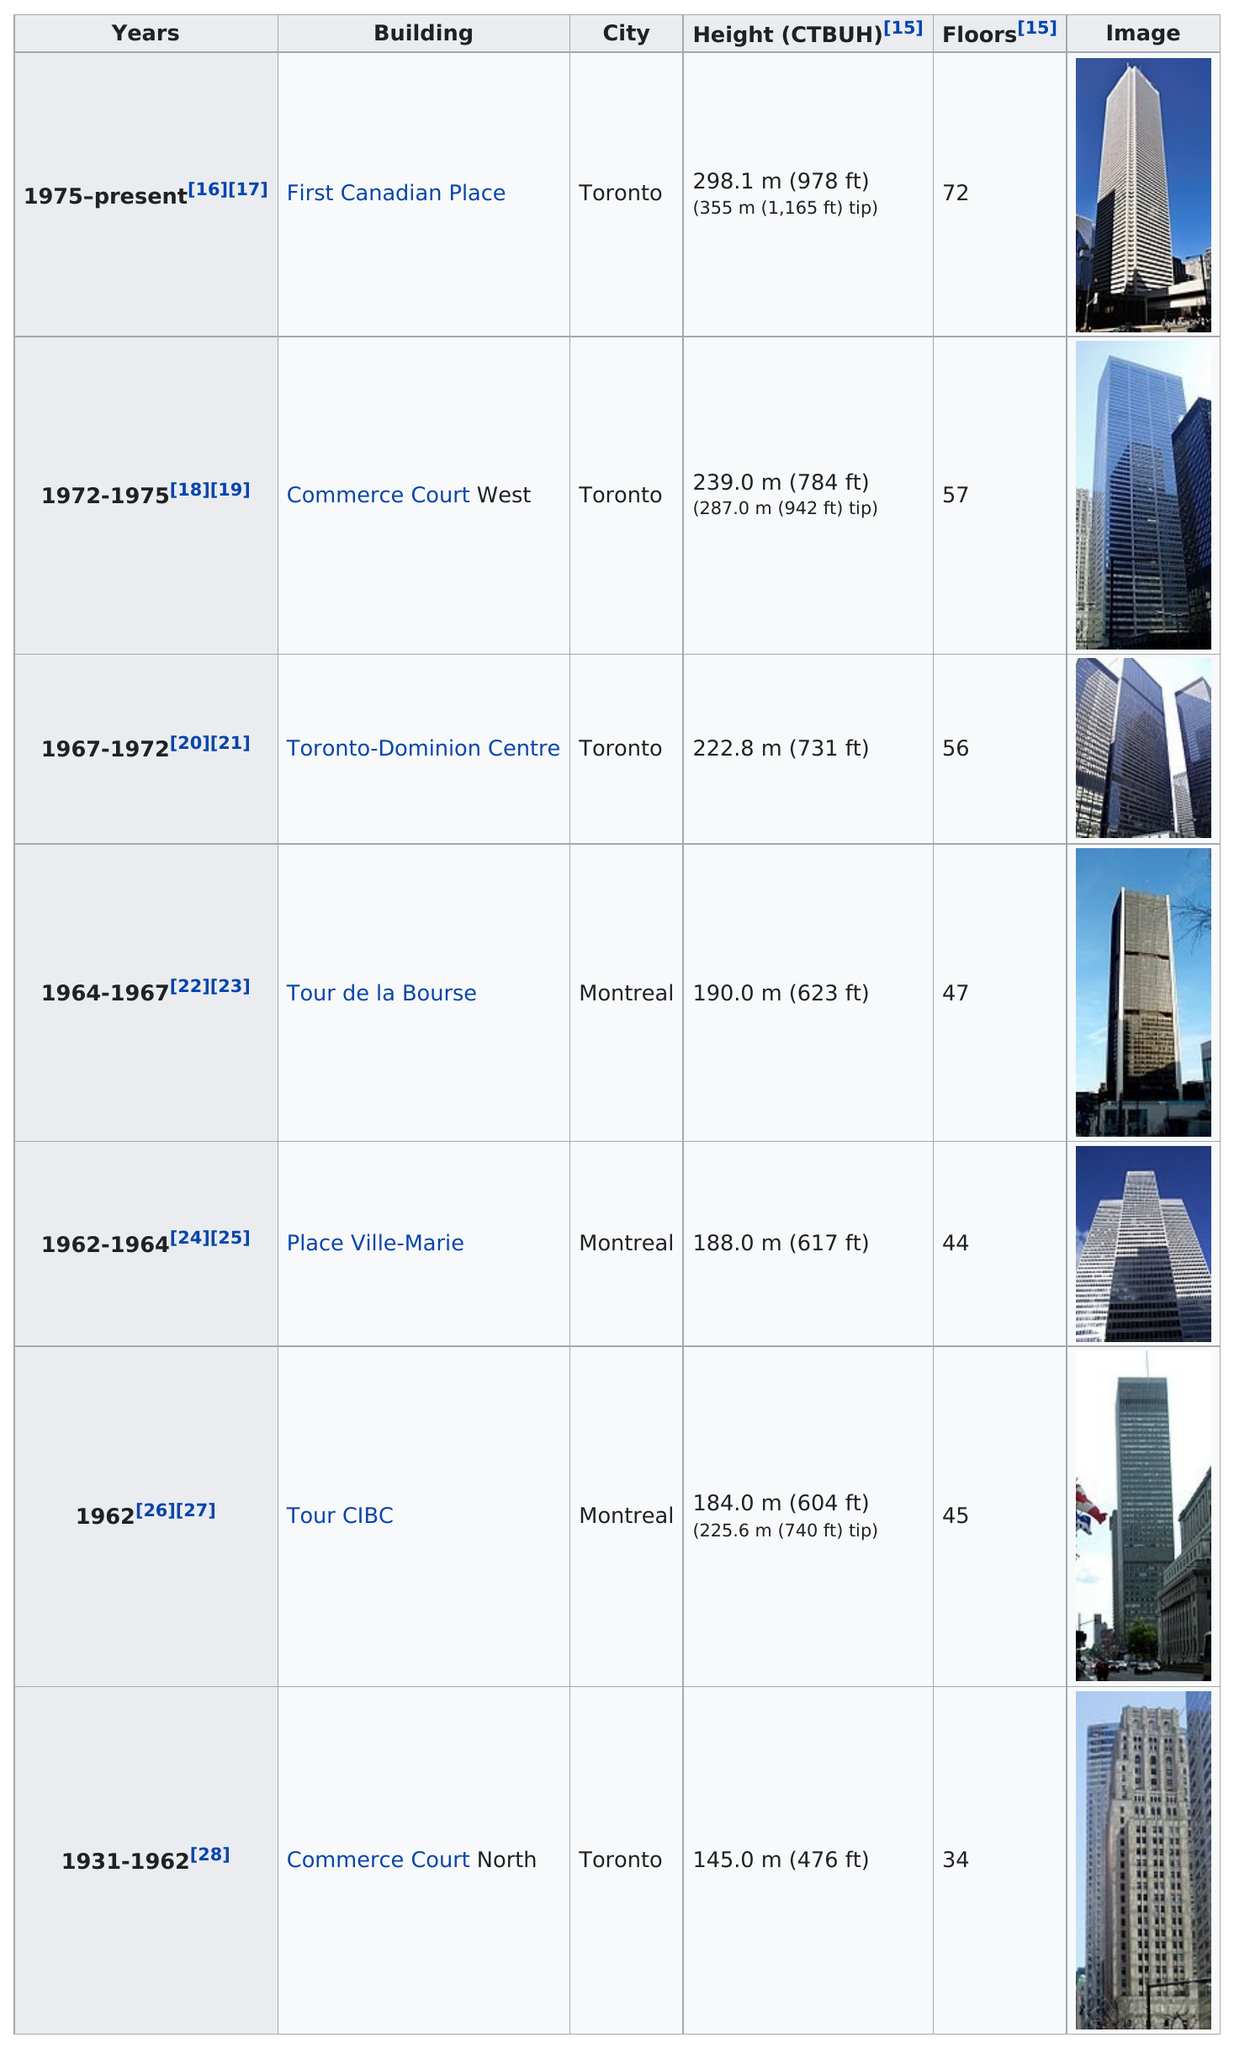Outline some significant characteristics in this image. Commerce Court West is the tallest building in Canada that contains the word "court" in its building name. Toronto is the first Canadian place and also home to Commerce Court West. The current record holder for tallest building in Toronto is Commerce Court West. Prior to its current title, Commerce Court West held the record for the tallest building in Toronto before being surpassed by the current holder. The Tour CIBC holds the record for being the only one to hold this title for a year. Four of the tallest buildings were located in Toronto. 